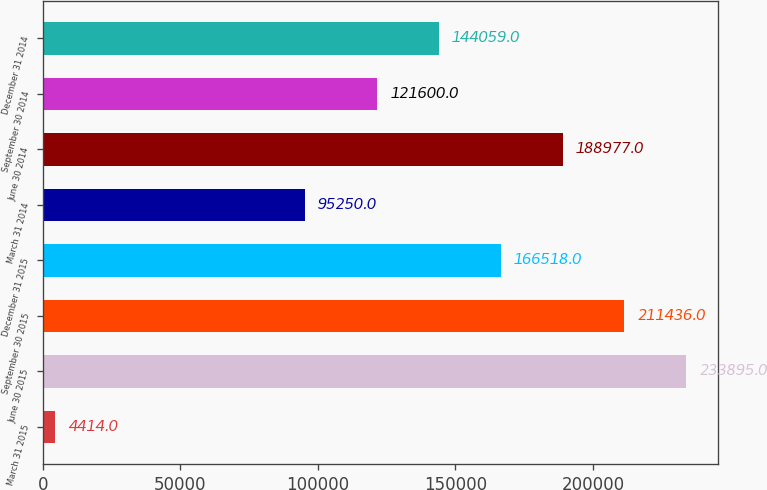Convert chart to OTSL. <chart><loc_0><loc_0><loc_500><loc_500><bar_chart><fcel>March 31 2015<fcel>June 30 2015<fcel>September 30 2015<fcel>December 31 2015<fcel>March 31 2014<fcel>June 30 2014<fcel>September 30 2014<fcel>December 31 2014<nl><fcel>4414<fcel>233895<fcel>211436<fcel>166518<fcel>95250<fcel>188977<fcel>121600<fcel>144059<nl></chart> 